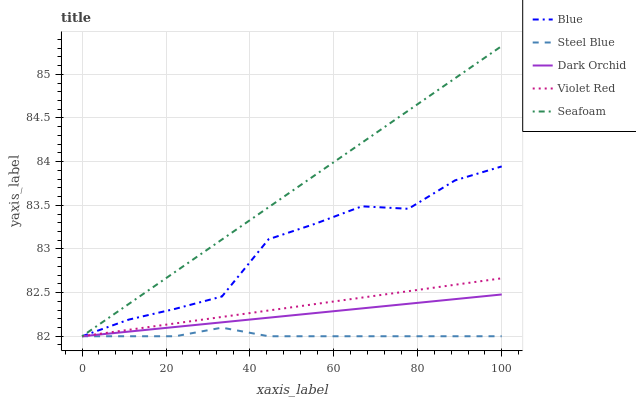Does Steel Blue have the minimum area under the curve?
Answer yes or no. Yes. Does Seafoam have the maximum area under the curve?
Answer yes or no. Yes. Does Violet Red have the minimum area under the curve?
Answer yes or no. No. Does Violet Red have the maximum area under the curve?
Answer yes or no. No. Is Violet Red the smoothest?
Answer yes or no. Yes. Is Blue the roughest?
Answer yes or no. Yes. Is Steel Blue the smoothest?
Answer yes or no. No. Is Steel Blue the roughest?
Answer yes or no. No. Does Blue have the lowest value?
Answer yes or no. Yes. Does Seafoam have the highest value?
Answer yes or no. Yes. Does Violet Red have the highest value?
Answer yes or no. No. Does Seafoam intersect Dark Orchid?
Answer yes or no. Yes. Is Seafoam less than Dark Orchid?
Answer yes or no. No. Is Seafoam greater than Dark Orchid?
Answer yes or no. No. 